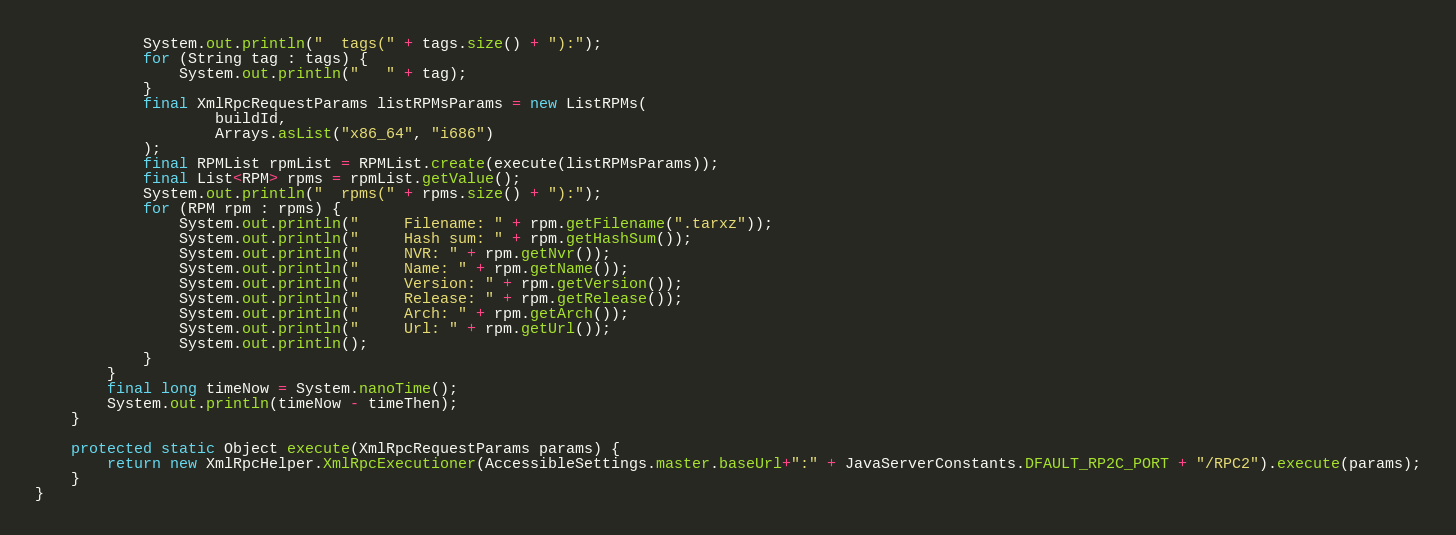<code> <loc_0><loc_0><loc_500><loc_500><_Java_>            System.out.println("  tags(" + tags.size() + "):");
            for (String tag : tags) {
                System.out.println("   " + tag);
            }
            final XmlRpcRequestParams listRPMsParams = new ListRPMs(
                    buildId,
                    Arrays.asList("x86_64", "i686")
            );
            final RPMList rpmList = RPMList.create(execute(listRPMsParams));
            final List<RPM> rpms = rpmList.getValue();
            System.out.println("  rpms(" + rpms.size() + "):");
            for (RPM rpm : rpms) {
                System.out.println("     Filename: " + rpm.getFilename(".tarxz"));
                System.out.println("     Hash sum: " + rpm.getHashSum());
                System.out.println("     NVR: " + rpm.getNvr());
                System.out.println("     Name: " + rpm.getName());
                System.out.println("     Version: " + rpm.getVersion());
                System.out.println("     Release: " + rpm.getRelease());
                System.out.println("     Arch: " + rpm.getArch());
                System.out.println("     Url: " + rpm.getUrl());
                System.out.println();
            }
        }
        final long timeNow = System.nanoTime();
        System.out.println(timeNow - timeThen);
    }

    protected static Object execute(XmlRpcRequestParams params) {
        return new XmlRpcHelper.XmlRpcExecutioner(AccessibleSettings.master.baseUrl+":" + JavaServerConstants.DFAULT_RP2C_PORT + "/RPC2").execute(params);
    }
}
</code> 